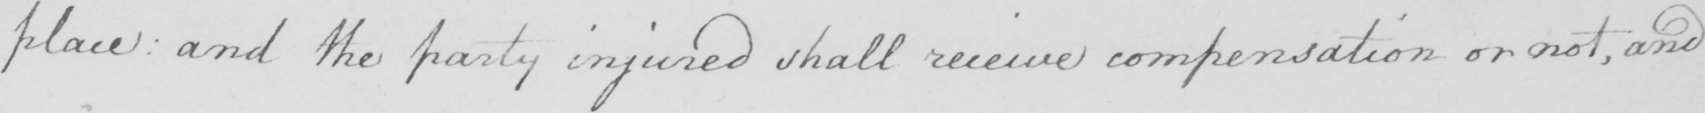What does this handwritten line say? place and the party injured shall receive compensation or not , and 